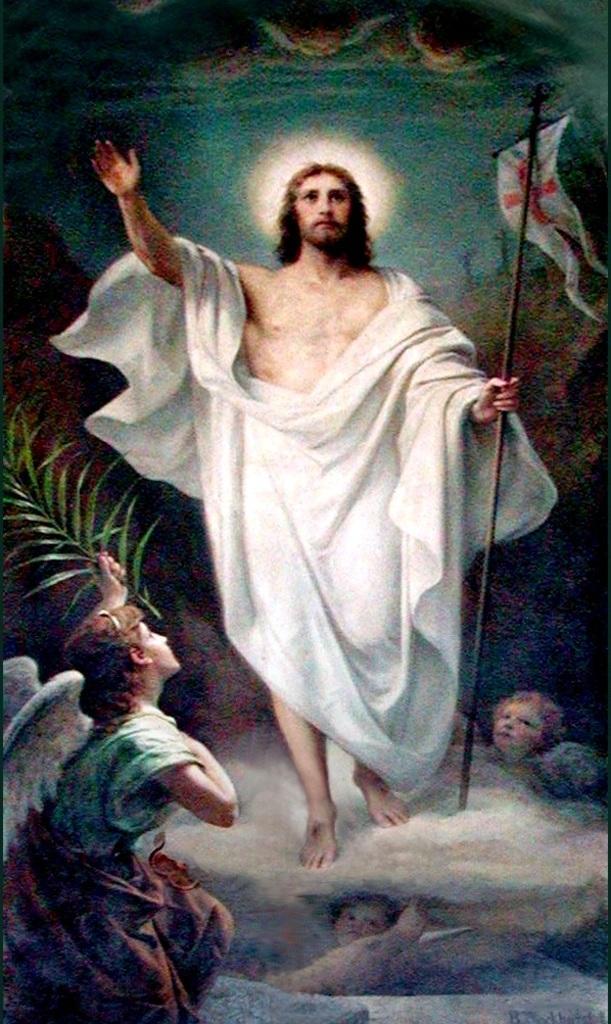Can you describe this image briefly? In this image I can see a painting in which I can see a person standing and holding a black colored metal rod. I can see a white colored cloth on him. I can see few children below him, a person sitting in front of him, a plant and in the background I can see the sky. 